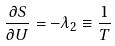<formula> <loc_0><loc_0><loc_500><loc_500>\frac { \partial S } { \partial U } = - \lambda _ { 2 } \equiv \frac { 1 } { T }</formula> 